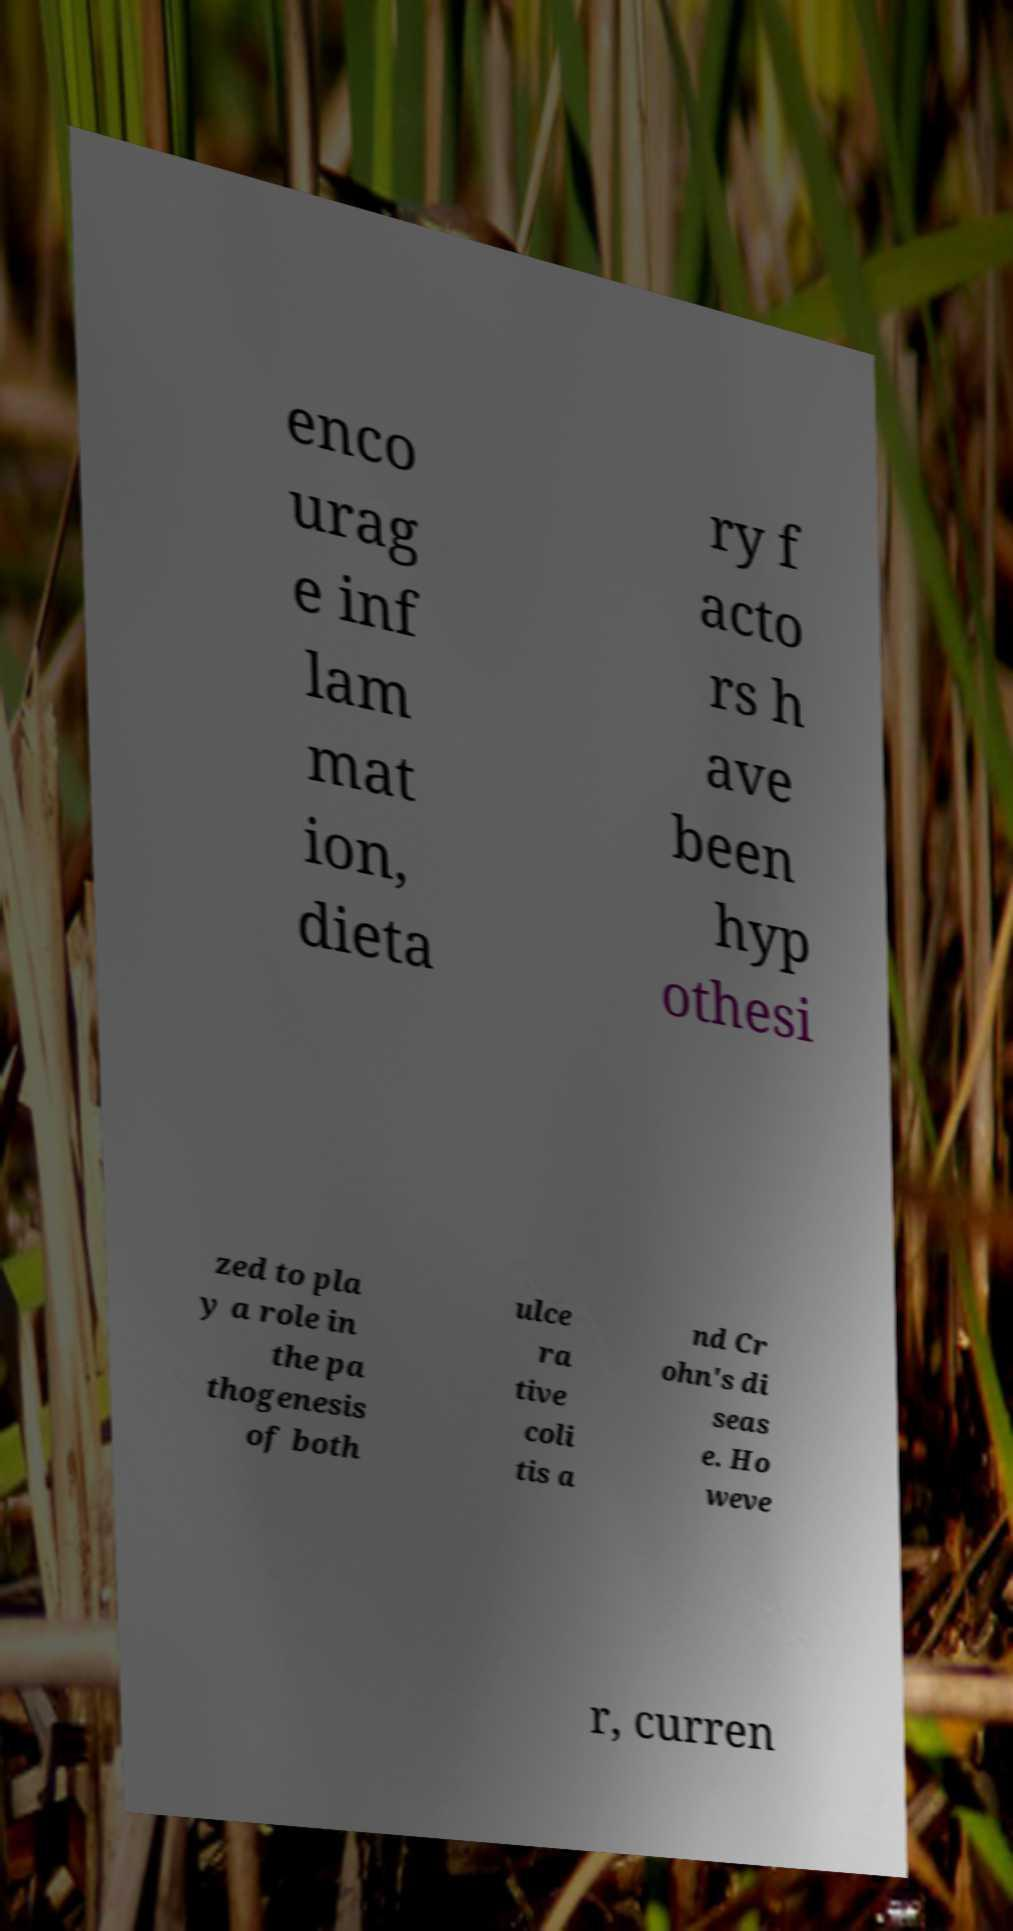Could you assist in decoding the text presented in this image and type it out clearly? enco urag e inf lam mat ion, dieta ry f acto rs h ave been hyp othesi zed to pla y a role in the pa thogenesis of both ulce ra tive coli tis a nd Cr ohn's di seas e. Ho weve r, curren 